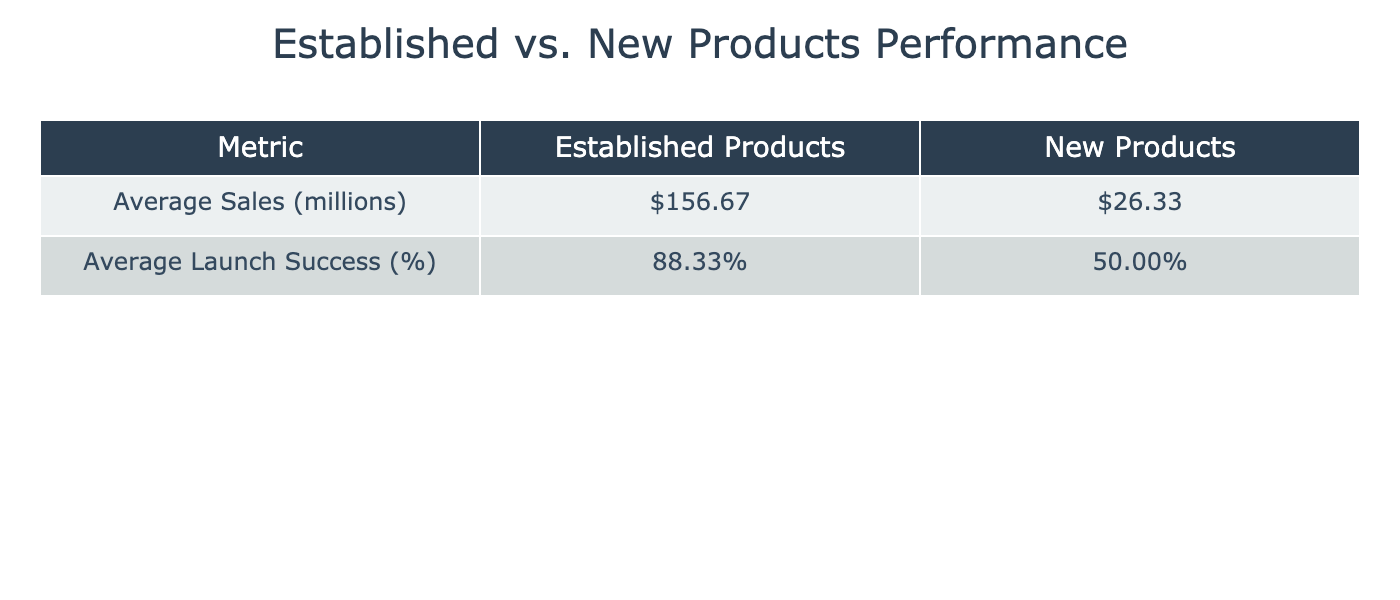What is the average sales performance of established products? The average sales performance for established products can be calculated by adding the sales figures: 215 + 150 + 120 + 100 + 175 + 180 = 1040. Then divide by the number of established products, which is 6. So 1040 / 6 = 173.33 million.
Answer: 173.33 million What is the average launch success rate of new products? To find the average launch success rate for new products, we add the success rates: 50 + 40 + 45 + 55 + 50 + 60 = 300. Dividing that total by the number of new products, which is 6, gives us 300 / 6 = 50%.
Answer: 50% Which category has higher average sales performance? From the calculations, established products have an average sales performance of 173.33 million and new products have an average of 26.33 million. Since 173.33 million is greater than 26.33 million, established products have higher average sales performance.
Answer: Established products What is the total sales performance of all new products combined? Adding the sales figures for new products: 25 + 18 + 30 + 22 + 28 + 35 = 158 million gives the total sales performance for new products.
Answer: 158 million Is the launch success rate of the iPhone 14 less than the launch success rate of the Galaxy S22? The launch success rate of the iPhone 14 is 90% and for the Galaxy S22, it is 88%. Since 90% is greater than 88%, this statement is false.
Answer: No What is the difference in average launch success rate between established and new products? The average launch success rate for established products is 88.33%, and for new products, it is 50%. The difference is 88.33 - 50 = 38.33%.
Answer: 38.33% Do established products generally have a higher launch success rate than new products? The average launch success rate for established products is 88.33%, while new products have an average of 50%. As 88.33% is greater than 50%, the statement is true.
Answer: Yes Which established product has the highest launch success rate? Looking at the launch success rates, the PlayStation 5 has the highest rate at 95%.
Answer: PlayStation 5 What is the average sales performance of new products? To find the average sales performance, sum the sales of new products: 25 + 18 + 30 + 22 + 28 + 35 = 158 million and divide by the number of new products, which is 6. Therefore, 158 / 6 = 26.33 million.
Answer: 26.33 million 